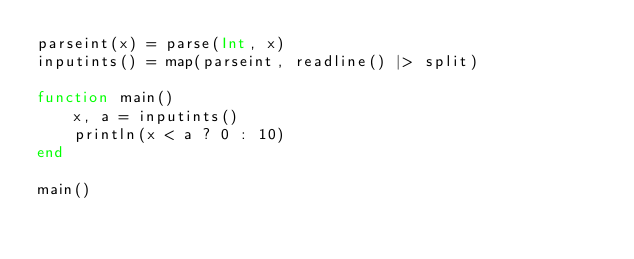Convert code to text. <code><loc_0><loc_0><loc_500><loc_500><_Julia_>parseint(x) = parse(Int, x)
inputints() = map(parseint, readline() |> split)

function main()
    x, a = inputints()
    println(x < a ? 0 : 10)
end

main()</code> 